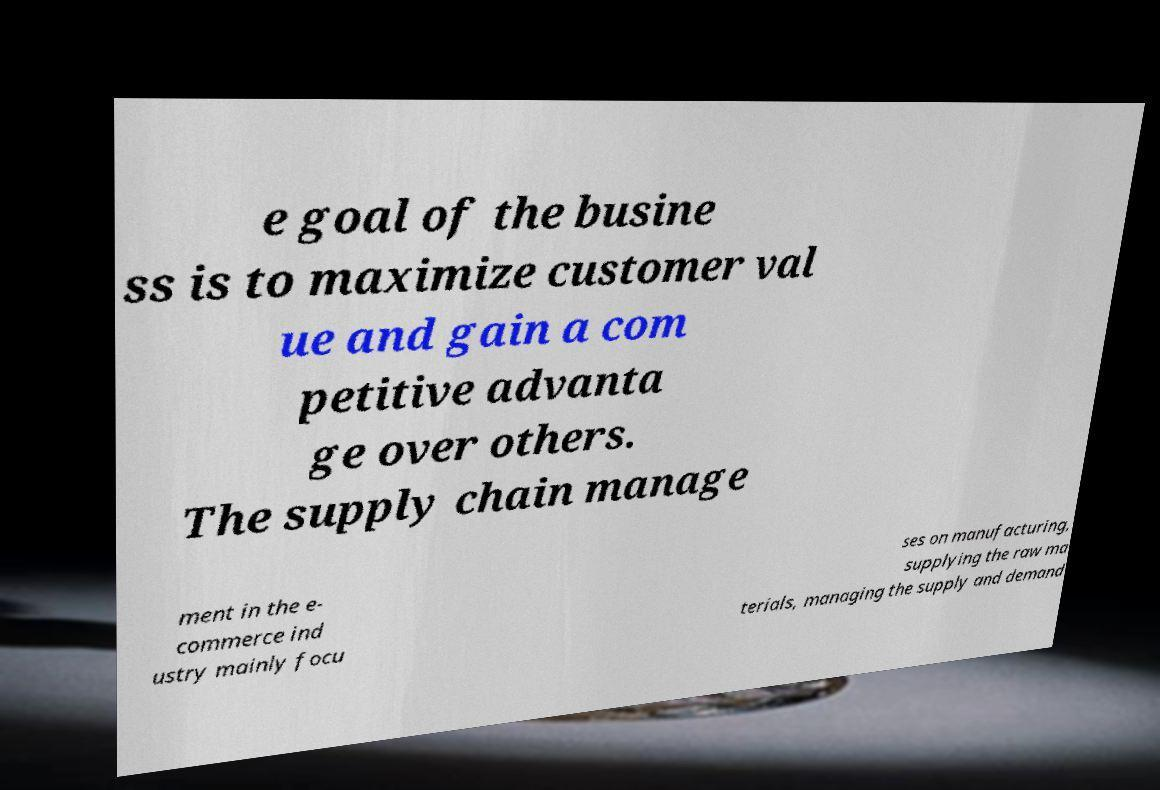Please read and relay the text visible in this image. What does it say? e goal of the busine ss is to maximize customer val ue and gain a com petitive advanta ge over others. The supply chain manage ment in the e- commerce ind ustry mainly focu ses on manufacturing, supplying the raw ma terials, managing the supply and demand 